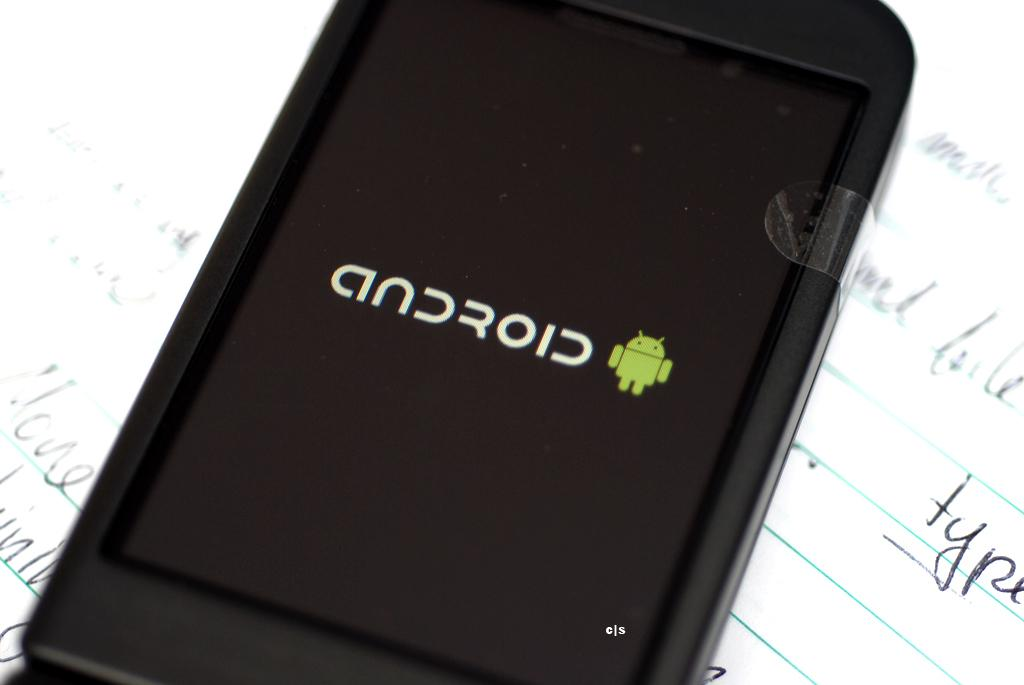<image>
Render a clear and concise summary of the photo. A back phone with the word android on its display. 